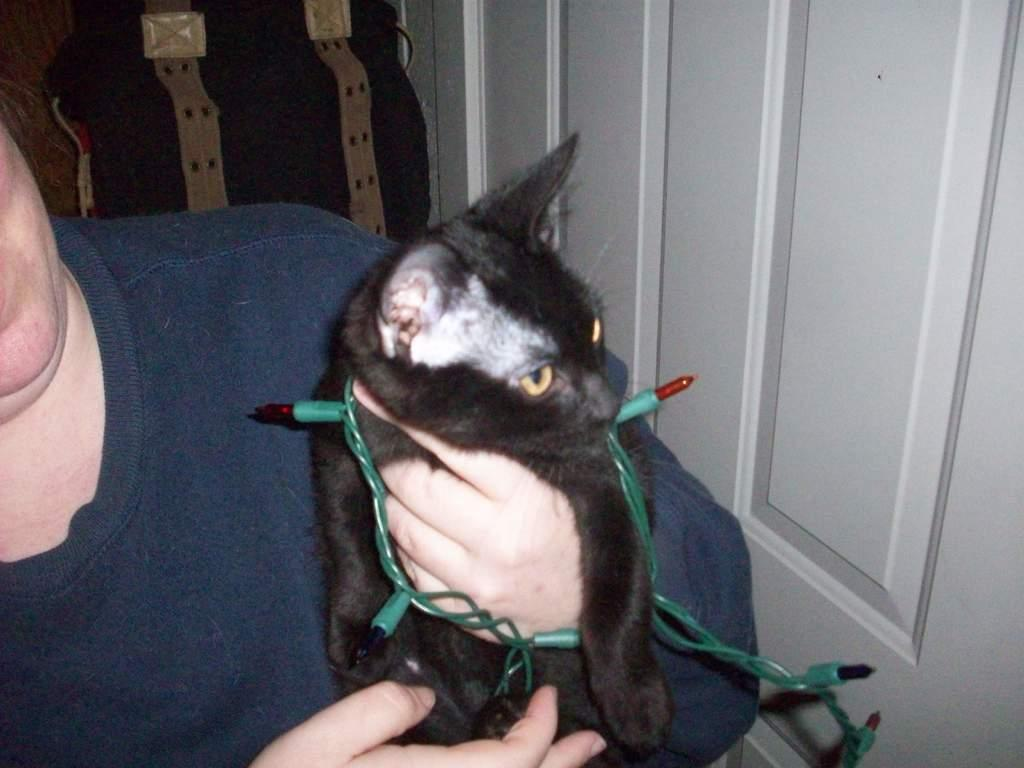What is the main subject of the image? There is a person in the image. What is the person holding in the image? The person is holding a cat. How is the cat decorated in the image? The cat is tied with decorative lights. What can be seen in the background of the image? There is a door visible in the background of the image. How many dimes are scattered on the floor in the image? There are no dimes visible on the floor in the image. What type of plastic material is used to make the cat's collar in the image? The cat is not wearing a collar in the image, and there is no mention of plastic material. 